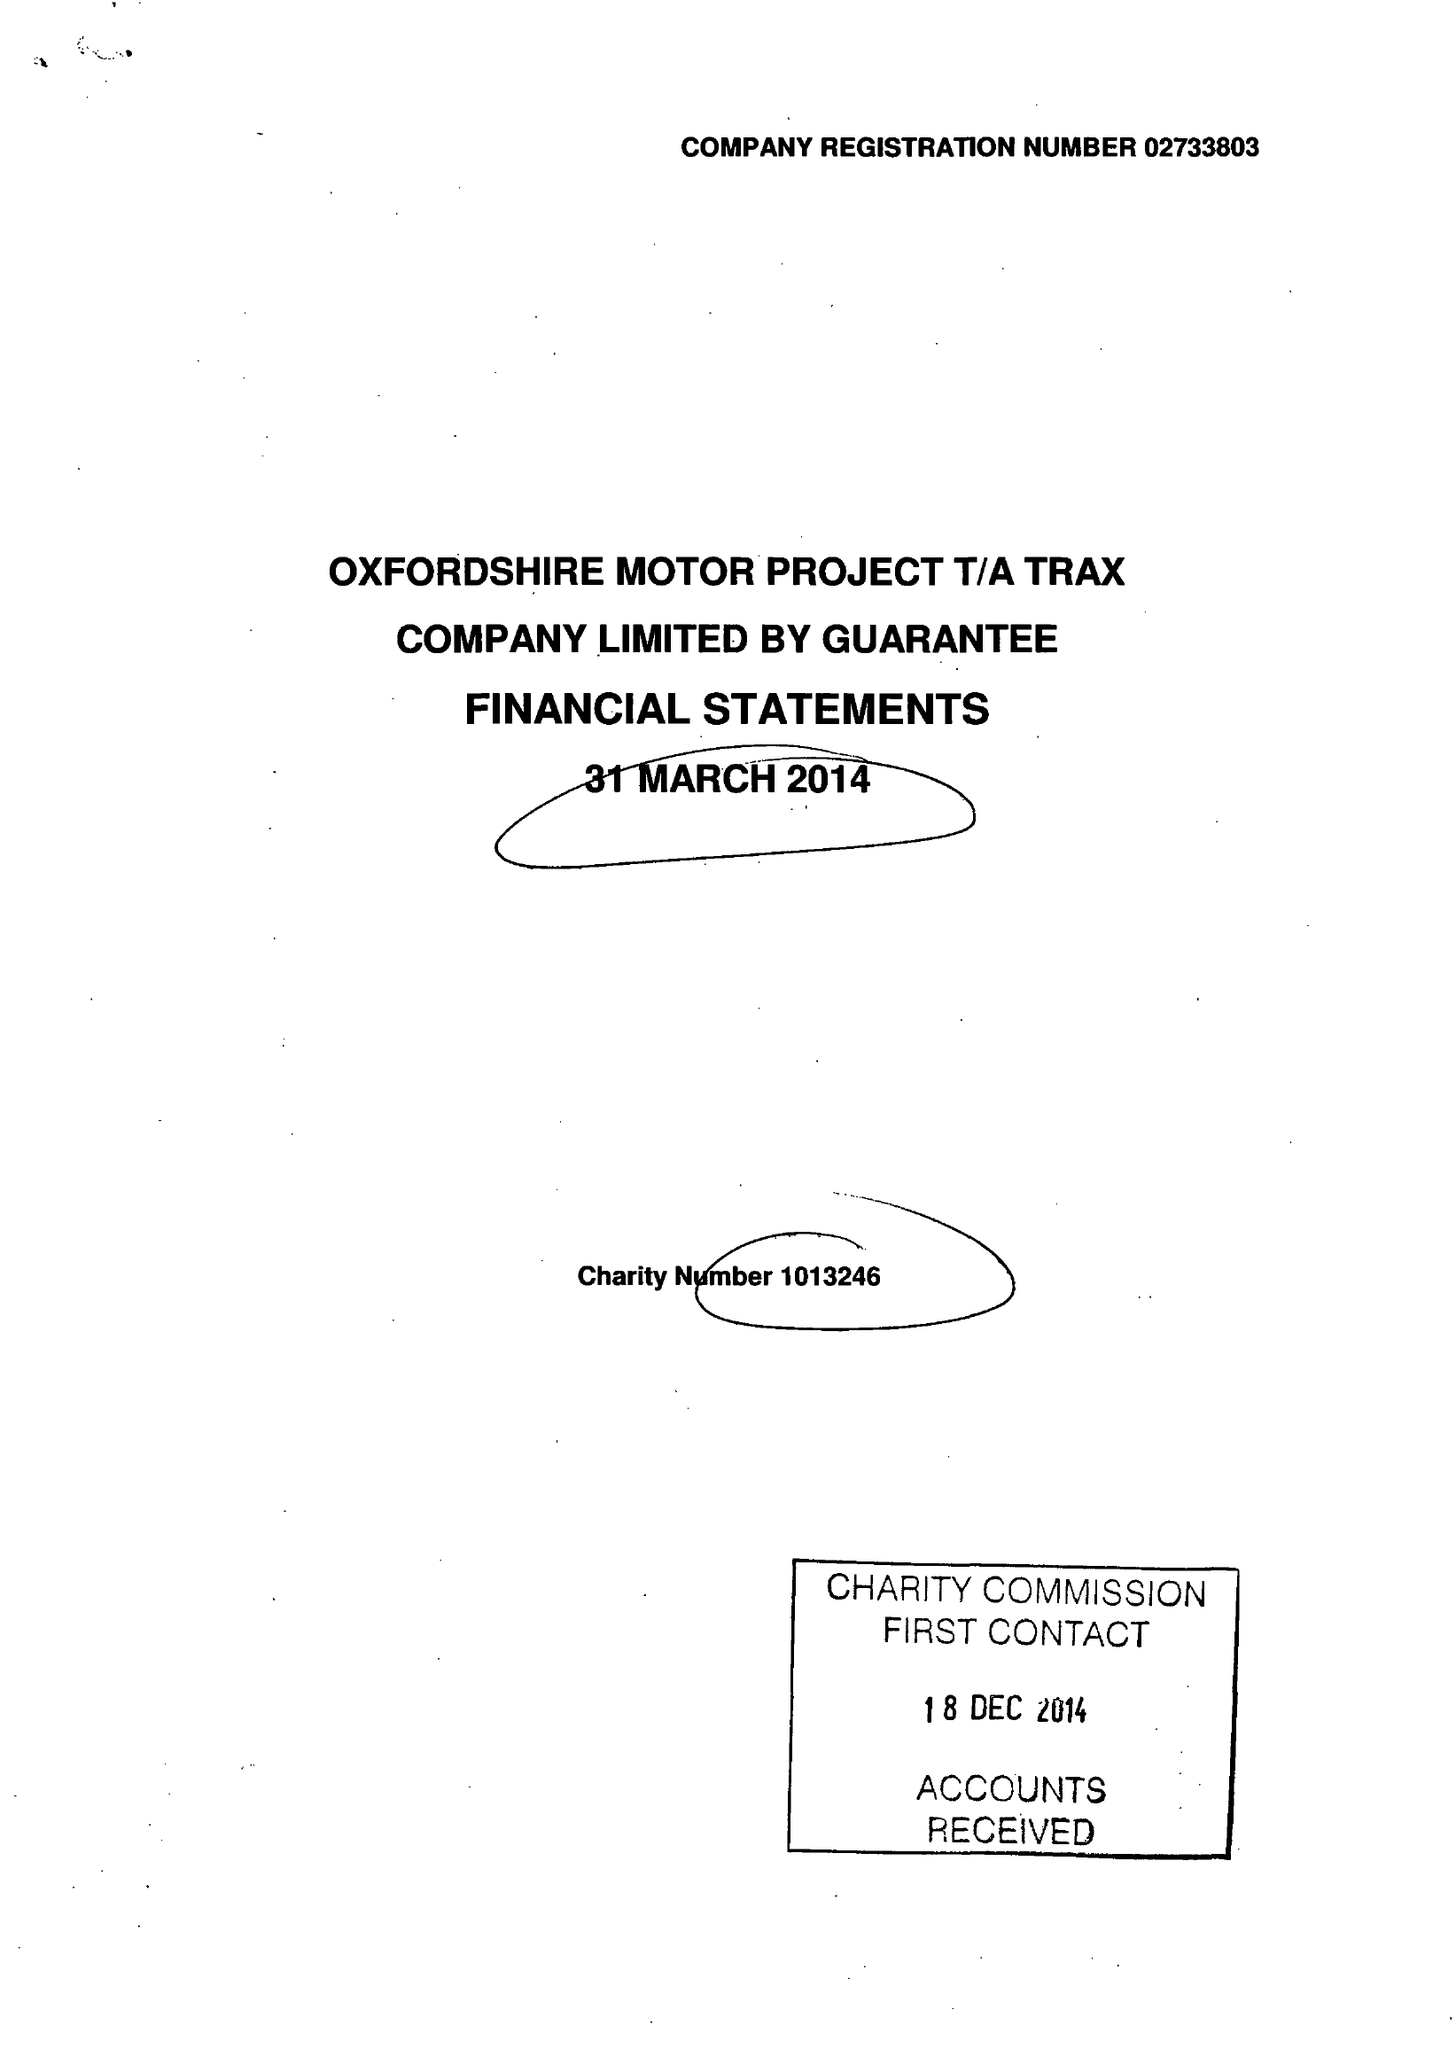What is the value for the address__postcode?
Answer the question using a single word or phrase. OX2 8JR 